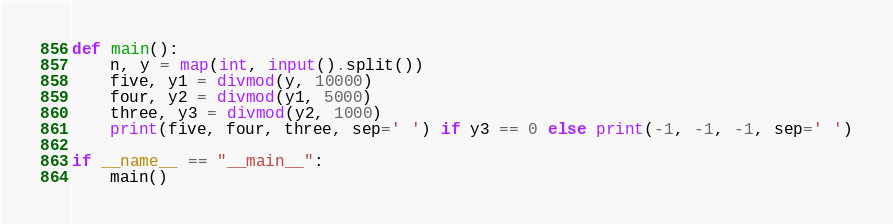Convert code to text. <code><loc_0><loc_0><loc_500><loc_500><_Python_>def main():
    n, y = map(int, input().split())
    five, y1 = divmod(y, 10000)
    four, y2 = divmod(y1, 5000)
    three, y3 = divmod(y2, 1000)
    print(five, four, three, sep=' ') if y3 == 0 else print(-1, -1, -1, sep=' ')

if __name__ == "__main__":
    main()</code> 